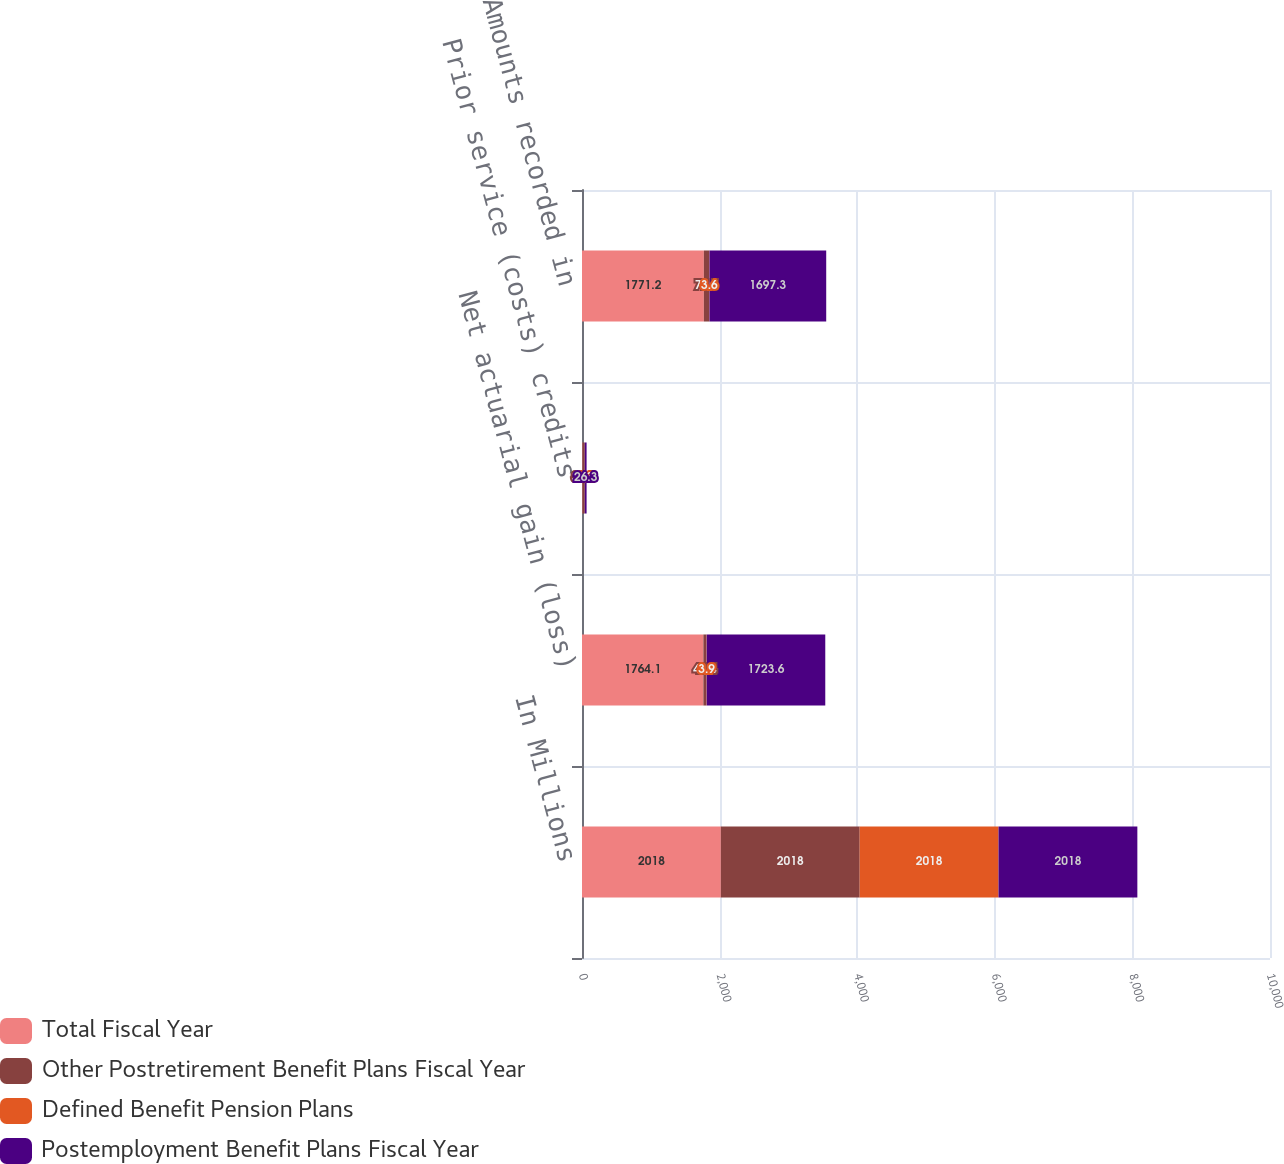Convert chart to OTSL. <chart><loc_0><loc_0><loc_500><loc_500><stacked_bar_chart><ecel><fcel>In Millions<fcel>Net actuarial gain (loss)<fcel>Prior service (costs) credits<fcel>Amounts recorded in<nl><fcel>Total Fiscal Year<fcel>2018<fcel>1764.1<fcel>7.1<fcel>1771.2<nl><fcel>Other Postretirement Benefit Plans Fiscal Year<fcel>2018<fcel>44.4<fcel>33.1<fcel>77.5<nl><fcel>Defined Benefit Pension Plans<fcel>2018<fcel>3.9<fcel>0.3<fcel>3.6<nl><fcel>Postemployment Benefit Plans Fiscal Year<fcel>2018<fcel>1723.6<fcel>26.3<fcel>1697.3<nl></chart> 